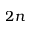Convert formula to latex. <formula><loc_0><loc_0><loc_500><loc_500>2 n</formula> 